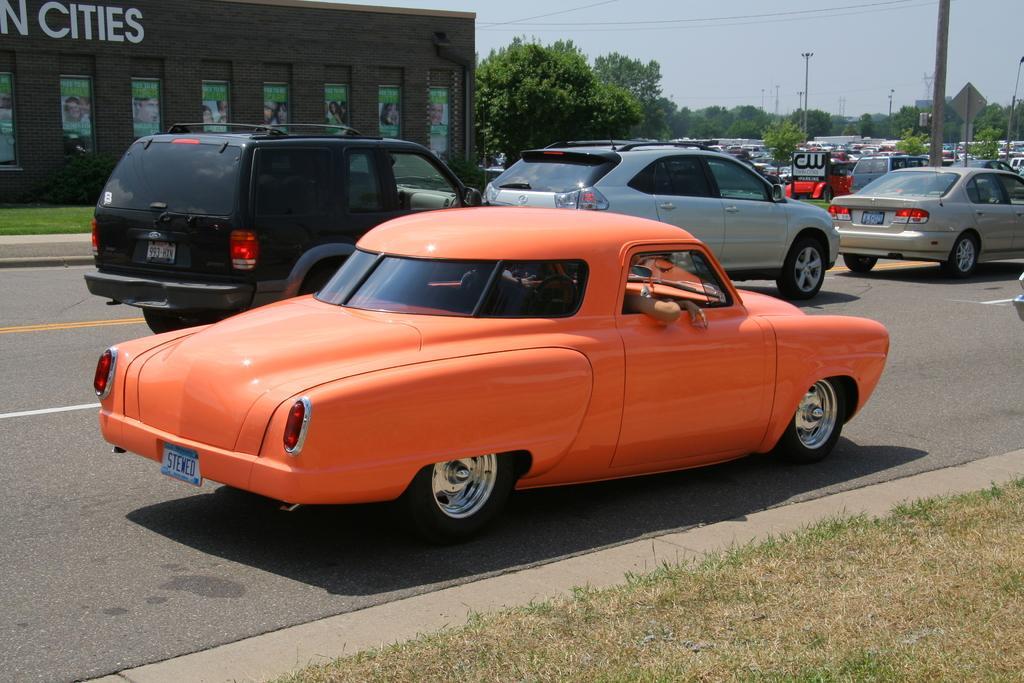In one or two sentences, can you explain what this image depicts? In this image we can see a group of vehicles. Behind the vehicles we can see plants, trees, poles and a building. On the building we can see the text and banners with images. At the top we can see the sky and the wires. At the bottom we can see the grass. 